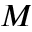Convert formula to latex. <formula><loc_0><loc_0><loc_500><loc_500>M</formula> 